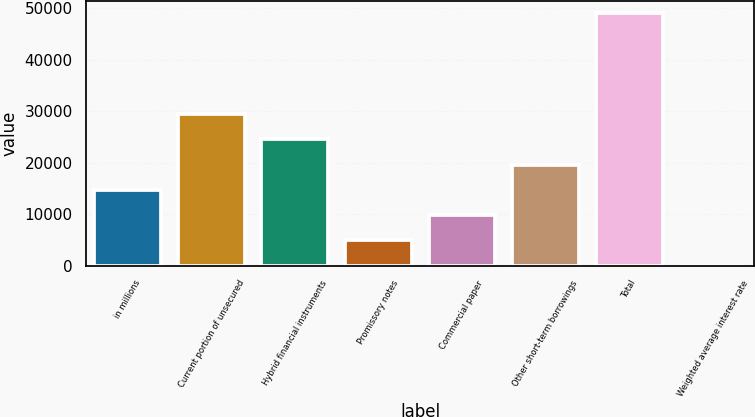Convert chart to OTSL. <chart><loc_0><loc_0><loc_500><loc_500><bar_chart><fcel>in millions<fcel>Current portion of unsecured<fcel>Hybrid financial instruments<fcel>Promissory notes<fcel>Commercial paper<fcel>Other short-term borrowings<fcel>Total<fcel>Weighted average interest rate<nl><fcel>14712.7<fcel>29423.5<fcel>24519.9<fcel>4905.5<fcel>9809.11<fcel>19616.3<fcel>49038<fcel>1.89<nl></chart> 